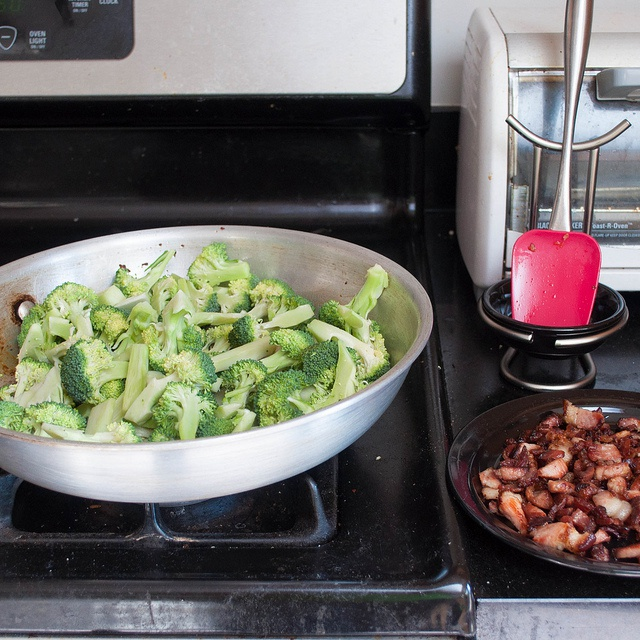Describe the objects in this image and their specific colors. I can see oven in black, lightgray, darkgray, and gray tones, bowl in black, lightgray, darkgray, olive, and beige tones, broccoli in black, beige, olive, lightgreen, and green tones, spoon in black, brown, lightgray, salmon, and gray tones, and bowl in black, gray, and maroon tones in this image. 